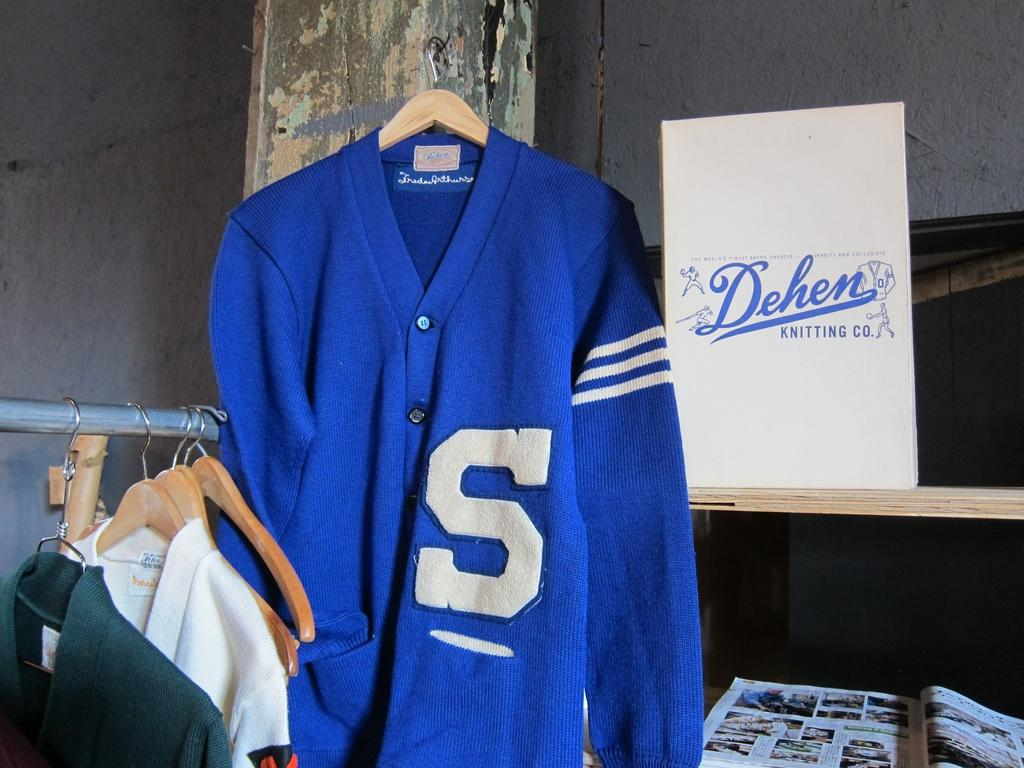<image>
Provide a brief description of the given image. A letterman sweater with an S on it with Dehen Kinniting co. advertisement next to it. 